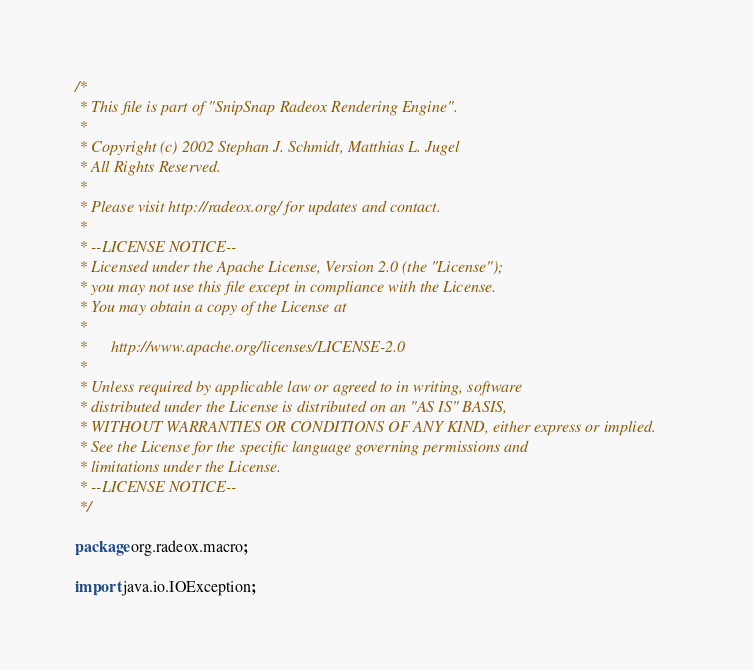<code> <loc_0><loc_0><loc_500><loc_500><_Java_>/*
 * This file is part of "SnipSnap Radeox Rendering Engine".
 *
 * Copyright (c) 2002 Stephan J. Schmidt, Matthias L. Jugel
 * All Rights Reserved.
 *
 * Please visit http://radeox.org/ for updates and contact.
 *
 * --LICENSE NOTICE--
 * Licensed under the Apache License, Version 2.0 (the "License");
 * you may not use this file except in compliance with the License.
 * You may obtain a copy of the License at
 *
 *      http://www.apache.org/licenses/LICENSE-2.0
 *
 * Unless required by applicable law or agreed to in writing, software
 * distributed under the License is distributed on an "AS IS" BASIS,
 * WITHOUT WARRANTIES OR CONDITIONS OF ANY KIND, either express or implied.
 * See the License for the specific language governing permissions and
 * limitations under the License.
 * --LICENSE NOTICE--
 */

package org.radeox.macro;

import java.io.IOException;</code> 